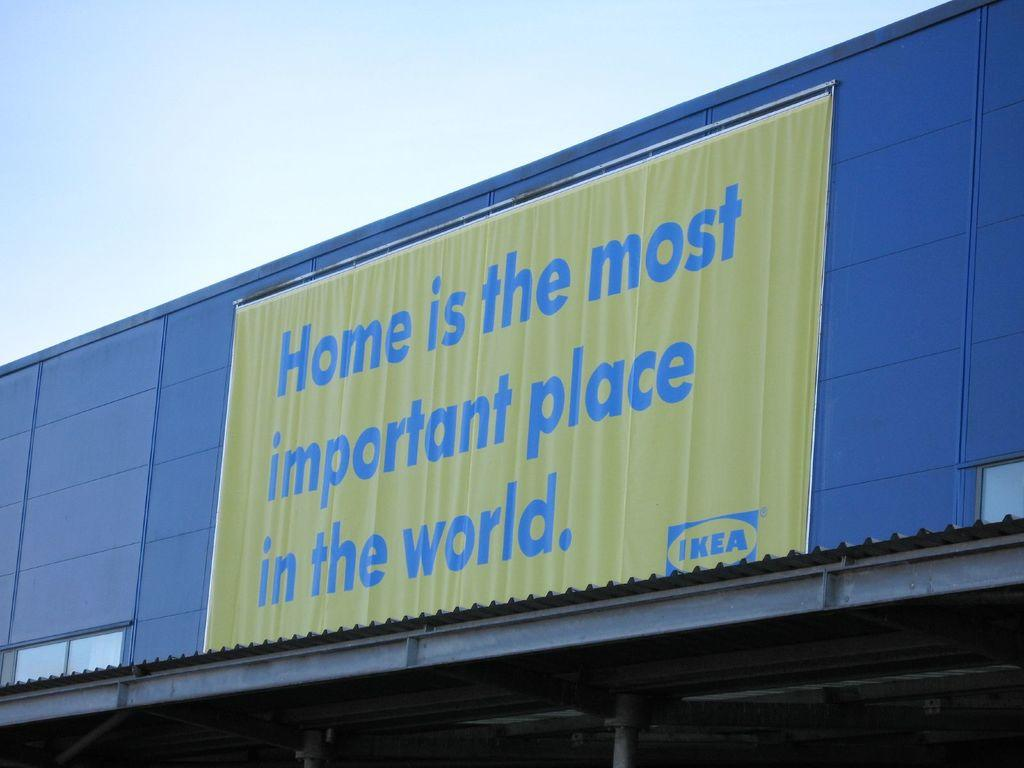Provide a one-sentence caption for the provided image. A store front of IKEA store with a banner that says "Home is the most important place in the world.". 